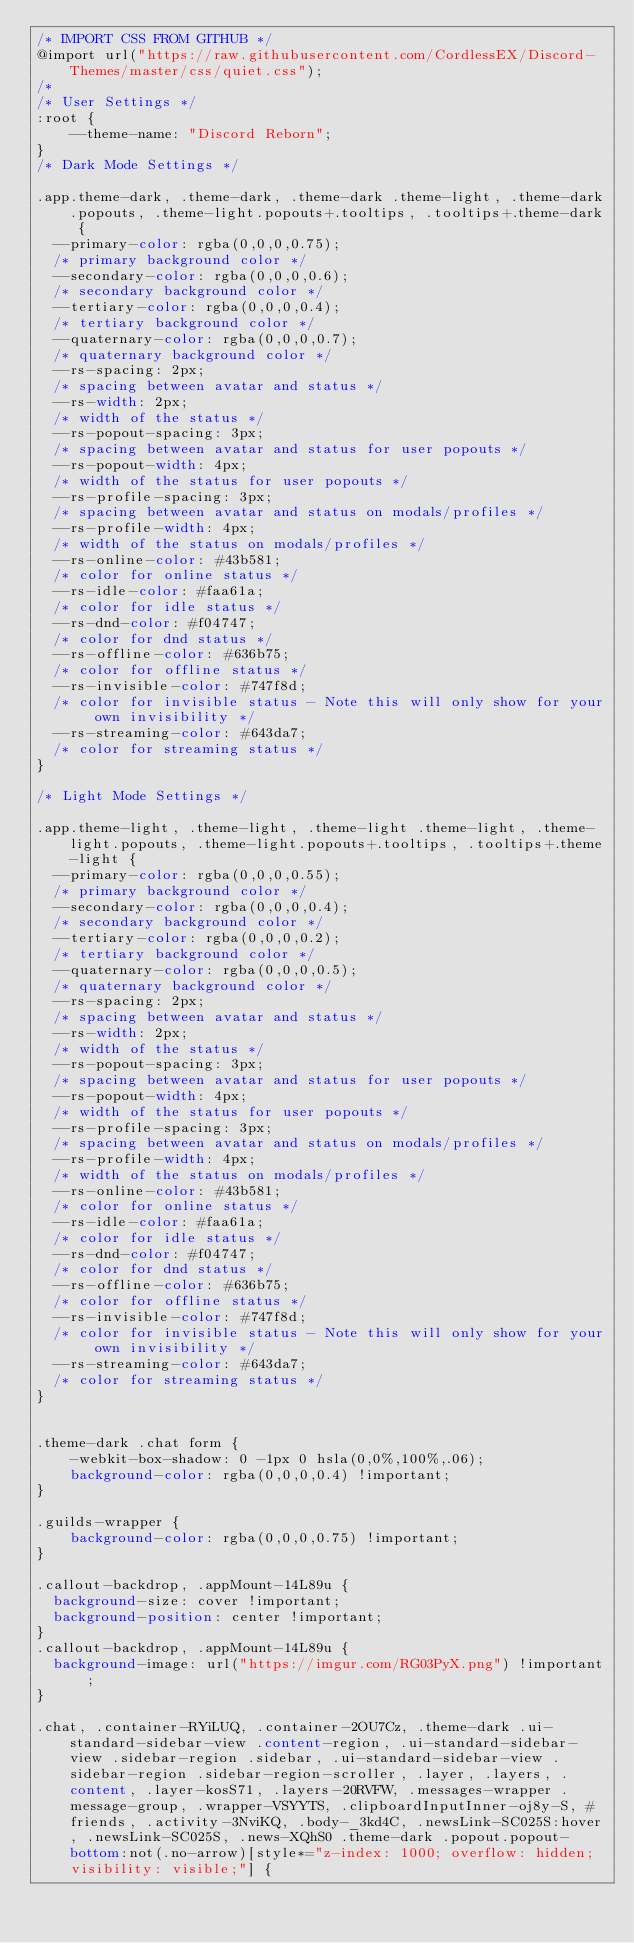<code> <loc_0><loc_0><loc_500><loc_500><_CSS_>/* IMPORT CSS FROM GITHUB */
@import url("https://raw.githubusercontent.com/CordlessEX/Discord-Themes/master/css/quiet.css");
/*
/* User Settings */
:root {
    --theme-name: "Discord Reborn";
}
/* Dark Mode Settings */

.app.theme-dark, .theme-dark, .theme-dark .theme-light, .theme-dark.popouts, .theme-light.popouts+.tooltips, .tooltips+.theme-dark {
  --primary-color: rgba(0,0,0,0.75);
  /* primary background color */
  --secondary-color: rgba(0,0,0,0.6);
  /* secondary background color */
  --tertiary-color: rgba(0,0,0,0.4);
  /* tertiary background color */
  --quaternary-color: rgba(0,0,0,0.7);
  /* quaternary background color */
  --rs-spacing: 2px;
  /* spacing between avatar and status */
  --rs-width: 2px;
  /* width of the status */
  --rs-popout-spacing: 3px;
  /* spacing between avatar and status for user popouts */
  --rs-popout-width: 4px;
  /* width of the status for user popouts */
  --rs-profile-spacing: 3px;
  /* spacing between avatar and status on modals/profiles */
  --rs-profile-width: 4px;
  /* width of the status on modals/profiles */
  --rs-online-color: #43b581;
  /* color for online status */
  --rs-idle-color: #faa61a;
  /* color for idle status */
  --rs-dnd-color: #f04747;
  /* color for dnd status */
  --rs-offline-color: #636b75;
  /* color for offline status */
  --rs-invisible-color: #747f8d;
  /* color for invisible status - Note this will only show for your own invisibility */
  --rs-streaming-color: #643da7;
  /* color for streaming status */
}

/* Light Mode Settings */

.app.theme-light, .theme-light, .theme-light .theme-light, .theme-light.popouts, .theme-light.popouts+.tooltips, .tooltips+.theme-light {
  --primary-color: rgba(0,0,0,0.55);
  /* primary background color */
  --secondary-color: rgba(0,0,0,0.4);
  /* secondary background color */
  --tertiary-color: rgba(0,0,0,0.2);
  /* tertiary background color */
  --quaternary-color: rgba(0,0,0,0.5);
  /* quaternary background color */
  --rs-spacing: 2px;
  /* spacing between avatar and status */
  --rs-width: 2px;
  /* width of the status */
  --rs-popout-spacing: 3px;
  /* spacing between avatar and status for user popouts */
  --rs-popout-width: 4px;
  /* width of the status for user popouts */
  --rs-profile-spacing: 3px;
  /* spacing between avatar and status on modals/profiles */
  --rs-profile-width: 4px;
  /* width of the status on modals/profiles */
  --rs-online-color: #43b581;
  /* color for online status */
  --rs-idle-color: #faa61a;
  /* color for idle status */
  --rs-dnd-color: #f04747;
  /* color for dnd status */
  --rs-offline-color: #636b75;
  /* color for offline status */
  --rs-invisible-color: #747f8d;
  /* color for invisible status - Note this will only show for your own invisibility */
  --rs-streaming-color: #643da7;
  /* color for streaming status */
}


.theme-dark .chat form {
    -webkit-box-shadow: 0 -1px 0 hsla(0,0%,100%,.06);
    background-color: rgba(0,0,0,0.4) !important;
}

.guilds-wrapper {
    background-color: rgba(0,0,0,0.75) !important;
}

.callout-backdrop, .appMount-14L89u {
  background-size: cover !important;
  background-position: center !important;
}
.callout-backdrop, .appMount-14L89u {
  background-image: url("https://imgur.com/RG03PyX.png") !important;
}

.chat, .container-RYiLUQ, .container-2OU7Cz, .theme-dark .ui-standard-sidebar-view .content-region, .ui-standard-sidebar-view .sidebar-region .sidebar, .ui-standard-sidebar-view .sidebar-region .sidebar-region-scroller, .layer, .layers, .content, .layer-kosS71, .layers-20RVFW, .messages-wrapper .message-group, .wrapper-VSYYTS, .clipboardInputInner-oj8y-S, #friends, .activity-3NviKQ, .body-_3kd4C, .newsLink-SC025S:hover, .newsLink-SC025S, .news-XQhS0 .theme-dark .popout.popout-bottom:not(.no-arrow)[style*="z-index: 1000; overflow: hidden; visibility: visible;"] {</code> 